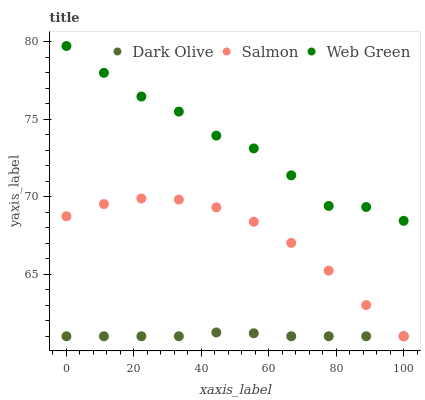Does Dark Olive have the minimum area under the curve?
Answer yes or no. Yes. Does Web Green have the maximum area under the curve?
Answer yes or no. Yes. Does Salmon have the minimum area under the curve?
Answer yes or no. No. Does Salmon have the maximum area under the curve?
Answer yes or no. No. Is Dark Olive the smoothest?
Answer yes or no. Yes. Is Web Green the roughest?
Answer yes or no. Yes. Is Salmon the smoothest?
Answer yes or no. No. Is Salmon the roughest?
Answer yes or no. No. Does Dark Olive have the lowest value?
Answer yes or no. Yes. Does Web Green have the lowest value?
Answer yes or no. No. Does Web Green have the highest value?
Answer yes or no. Yes. Does Salmon have the highest value?
Answer yes or no. No. Is Dark Olive less than Web Green?
Answer yes or no. Yes. Is Web Green greater than Salmon?
Answer yes or no. Yes. Does Dark Olive intersect Salmon?
Answer yes or no. Yes. Is Dark Olive less than Salmon?
Answer yes or no. No. Is Dark Olive greater than Salmon?
Answer yes or no. No. Does Dark Olive intersect Web Green?
Answer yes or no. No. 